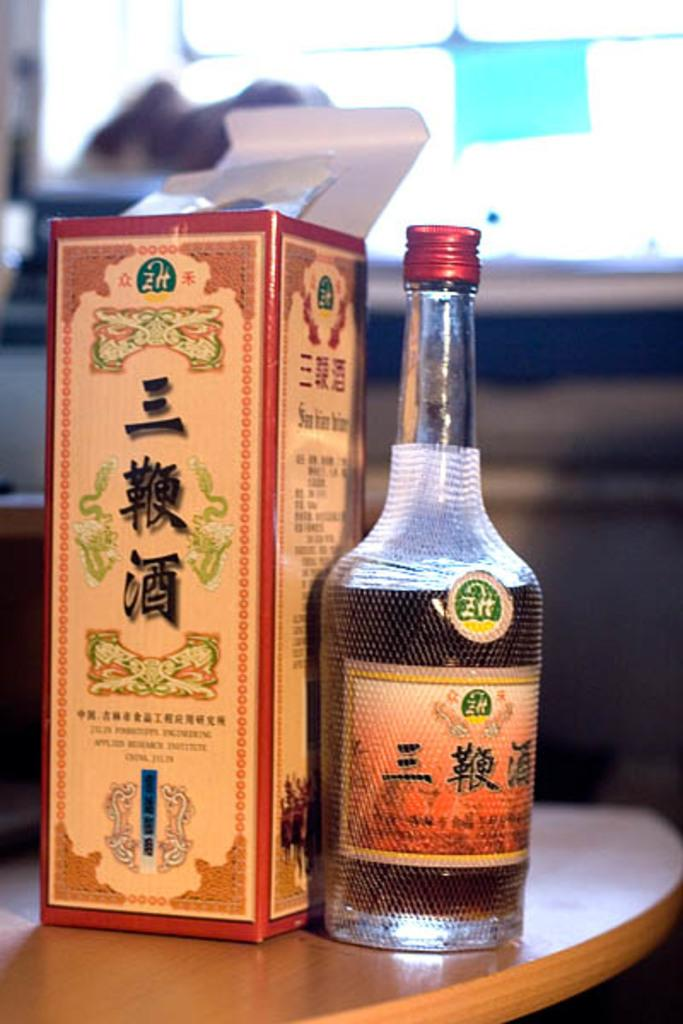<image>
Describe the image concisely. A bottle of some type of liquor sitting next to its box. It has asian writing on it 